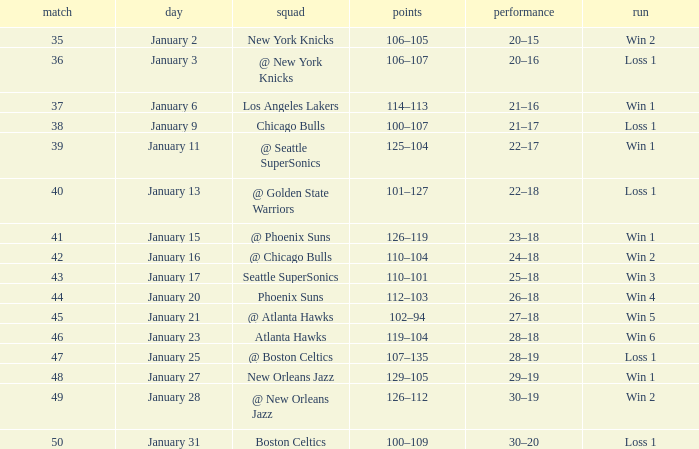What is the Streak in the game with a Record of 20–16? Loss 1. 